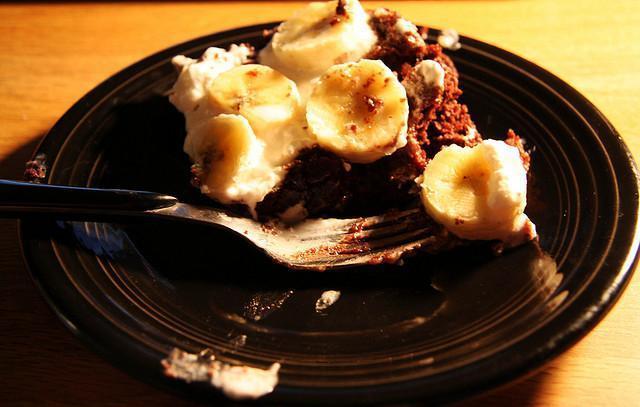How many bananas are there?
Give a very brief answer. 2. How many cakes are there?
Give a very brief answer. 1. How many people in white shirts are there?
Give a very brief answer. 0. 